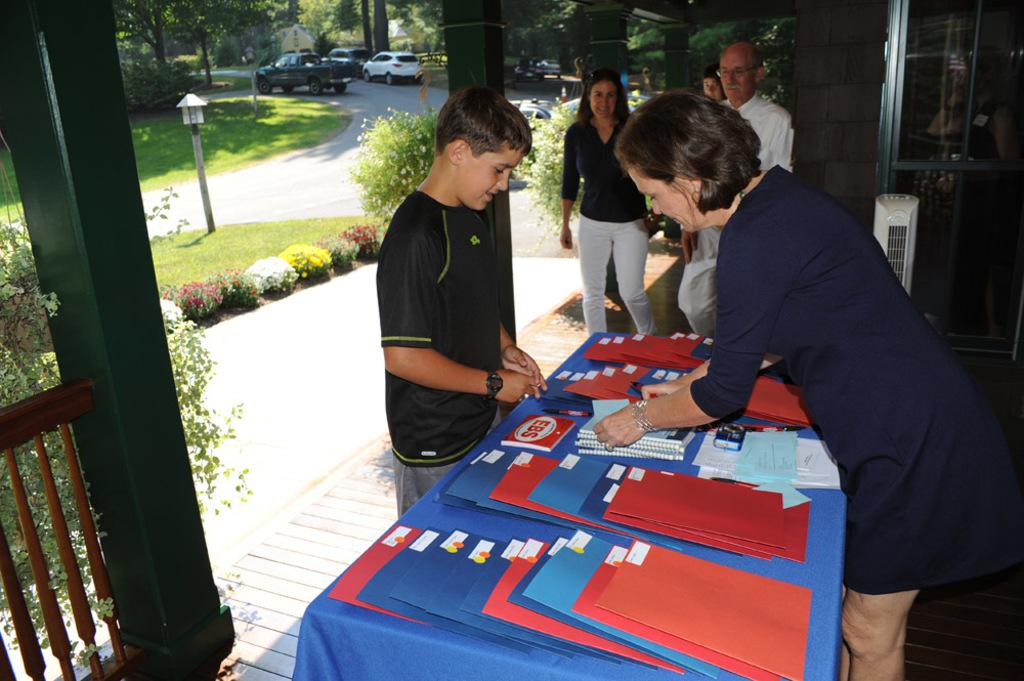How many people are in the group visible in the image? There is a group of persons in the image, but the exact number is not specified. What can be seen in the background of the image? There are cars and trees in the background of the image. What activity is the person on the right side of the image engaged in? There is a person selling books at the right side of the image. What type of ornament is hanging from the car in the image? There is no ornament hanging from a car in the image. Can you see any worms crawling on the trees in the image? There are no worms visible on the trees in the image. 